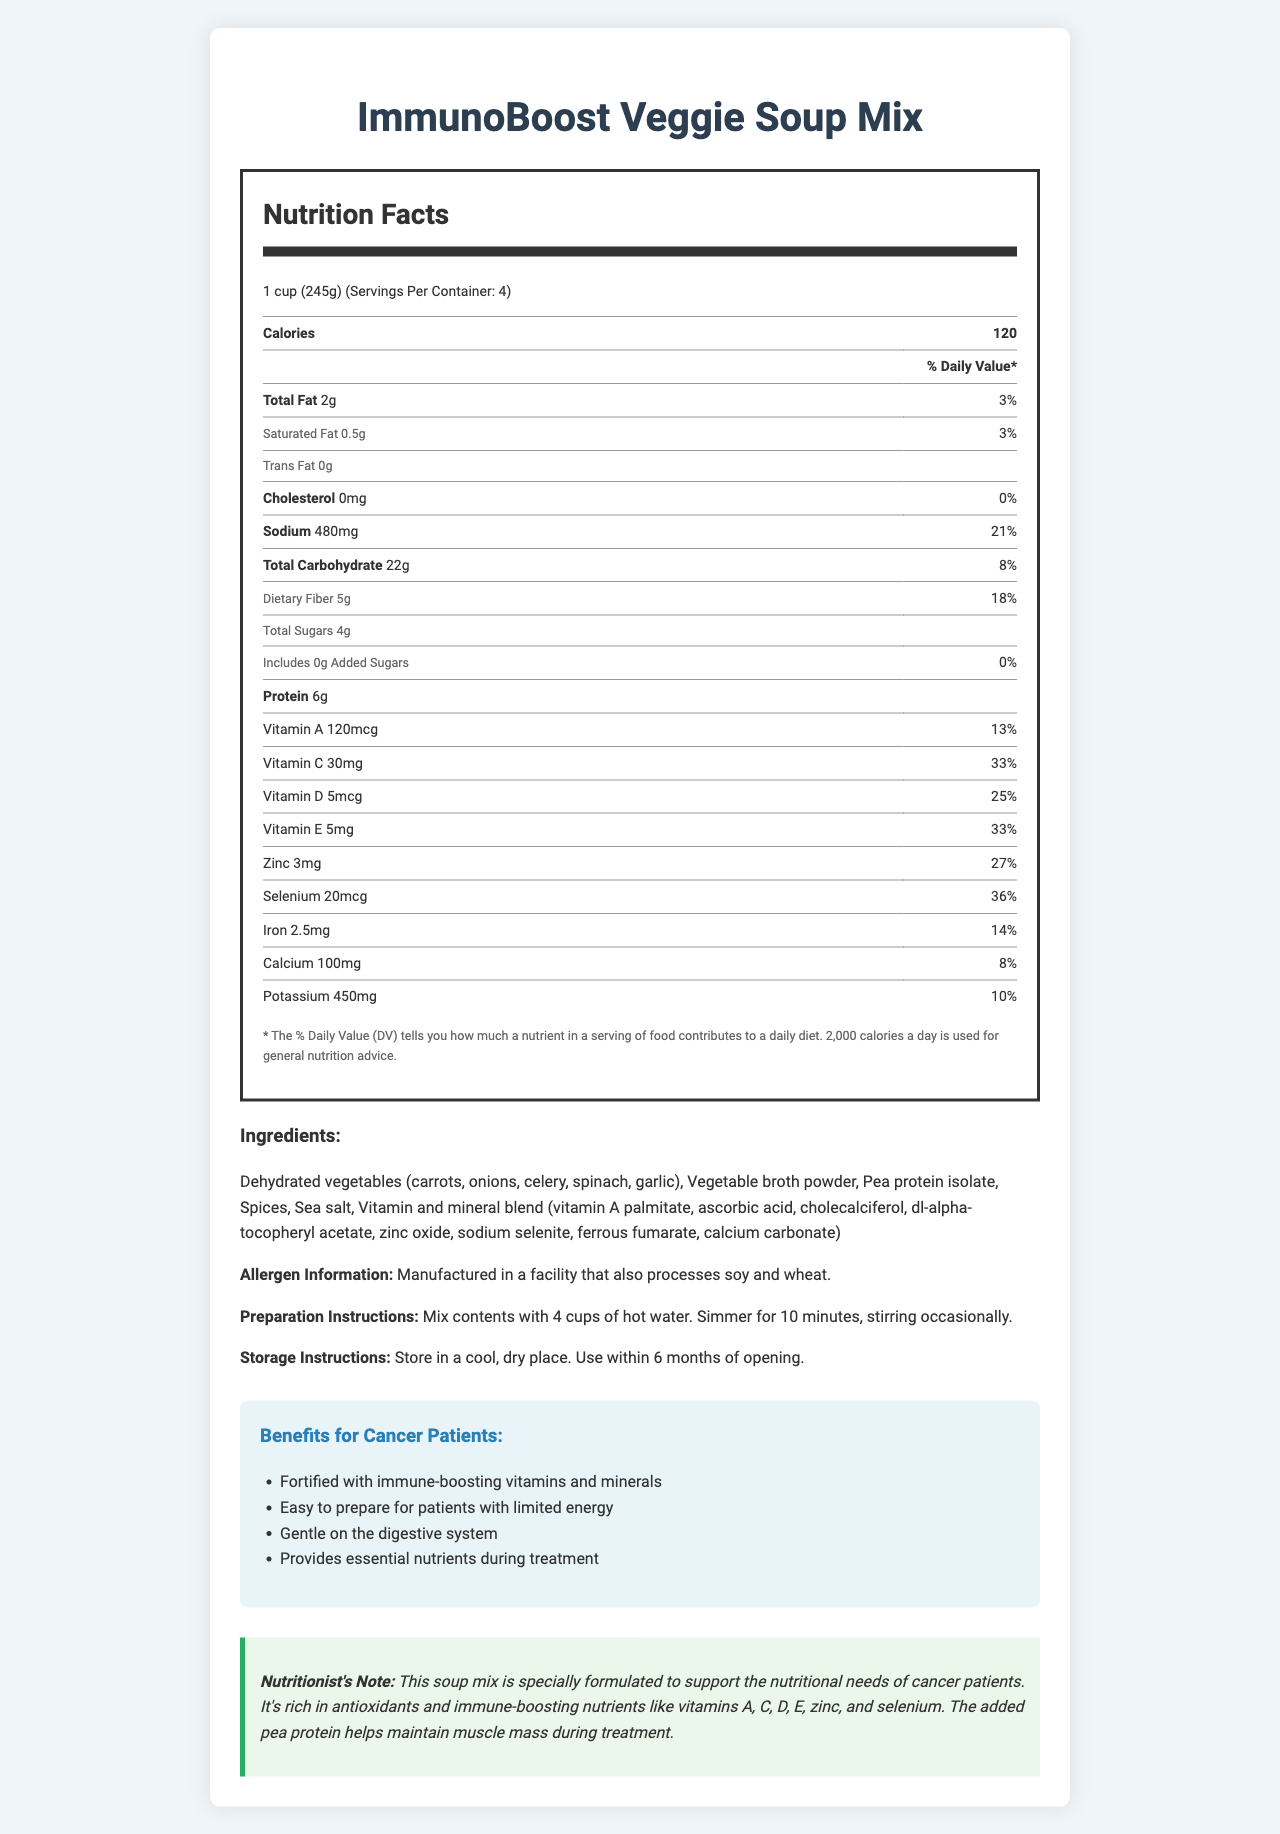what is the serving size of the ImmunoBoost Veggie Soup Mix? The serving size is mentioned at the start of the Nutrition Facts, which specifies "1 cup (245g)".
Answer: 1 cup (245g) how many calories are in one serving? The calories per serving are listed as 120 in the Nutrition Facts section.
Answer: 120 what is the percentage of daily value for sodium per serving? The percentage of daily value for sodium is displayed next to the sodium content, indicating 21%.
Answer: 21% what are the main benefits of this soup mix for cancer patients? The benefits are listed in the "Benefits for Cancer Patients" section.
Answer: Fortified with immune-boosting vitamins and minerals, easy to prepare for patients with limited energy, gentle on the digestive system, provides essential nutrients during treatment how should the ImmunoBoost Veggie Soup Mix be prepared? The preparation instructions specify these steps.
Answer: Mix contents with 4 cups of hot water. Simmer for 10 minutes, stirring occasionally. which vitamin has the highest daily value percentage in one serving of the soup mix? 
A. Vitamin A
B. Vitamin C
C. Vitamin D
D. Vitamin E The daily value percentages are shown in the Nutrition Facts, with Vitamin C having 33%, which is the highest.
Answer: B. Vitamin C what is the protein content per serving? 
A. 4g
B. 5g
C. 6g
D. 7g The protein content of 6g per serving is displayed in the Nutrition Facts.
Answer: C. 6g is there any cholesterol present in one serving of the soup mix? The document states that the cholesterol amount is 0mg, equating to 0% daily value.
Answer: No does this product contain any added sugars? The Nutrition Facts mention that "Includes 0g Added Sugars" with a daily value of 0%.
Answer: No what type of facility is the soup mix manufactured in concerning allergens? The allergen information mentions that the product is manufactured in a facility that processes soy and wheat.
Answer: A facility that also processes soy and wheat. summarize the main nutrition-related features and benefits of the ImmunoBoost Veggie Soup Mix for cancer patients. This summary covers the main points including the nutritional content, ease of preparation, and specific benefits for cancer patients.
Answer: The ImmunoBoost Veggie Soup Mix is a fortified vegetable soup mix designed to support cancer patients. It provides a variety of essential nutrients, including immune-boosting vitamins and minerals such as vitamins A, C, D, E, zinc, and selenium. The product is easy to prepare, making it suitable for patients with limited energy and gentle on the digestive system. It supports patients' nutritional needs during treatment with added pea protein to help maintain muscle mass. how much dietary fiber does one serving provide? The dietary fiber content is listed as 5g per serving in the Nutrition Facts.
Answer: 5g how should the soup mix be stored after opening? The storage instructions specify these details.
Answer: Store in a cool, dry place. Use within 6 months of opening. can someone determine the expiration date of the soup mix from the document? The document does not provide any information regarding the expiration date or shelf life of the soup mix.
Answer: Cannot be determined 